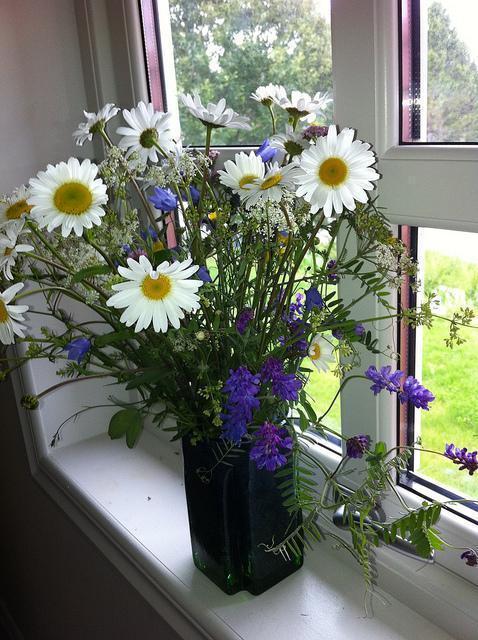How many different flowers are in the vase?
Give a very brief answer. 2. How many people are holding a bat?
Give a very brief answer. 0. 